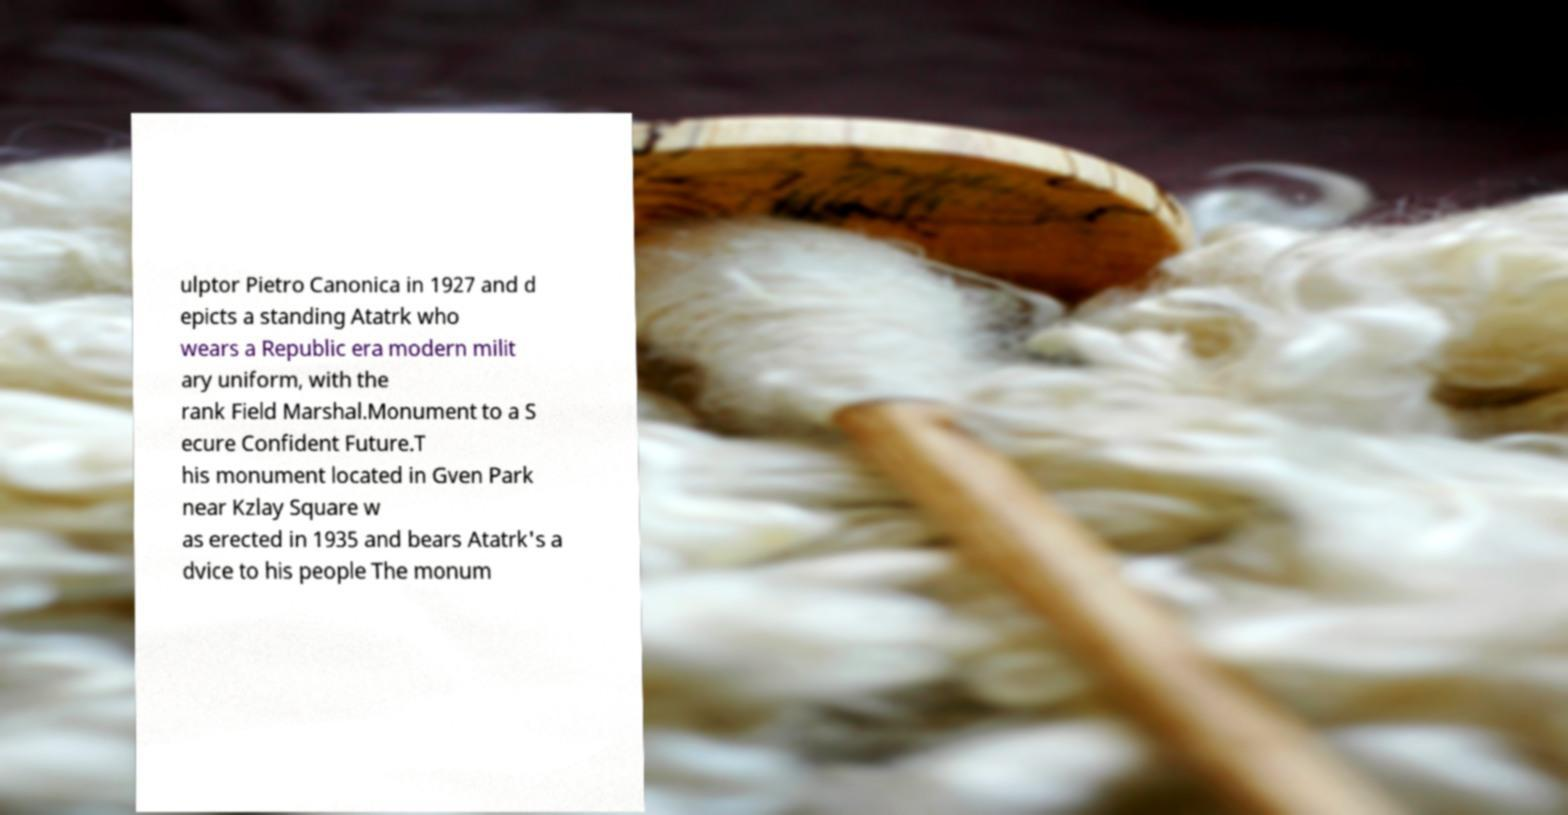Can you accurately transcribe the text from the provided image for me? ulptor Pietro Canonica in 1927 and d epicts a standing Atatrk who wears a Republic era modern milit ary uniform, with the rank Field Marshal.Monument to a S ecure Confident Future.T his monument located in Gven Park near Kzlay Square w as erected in 1935 and bears Atatrk's a dvice to his people The monum 